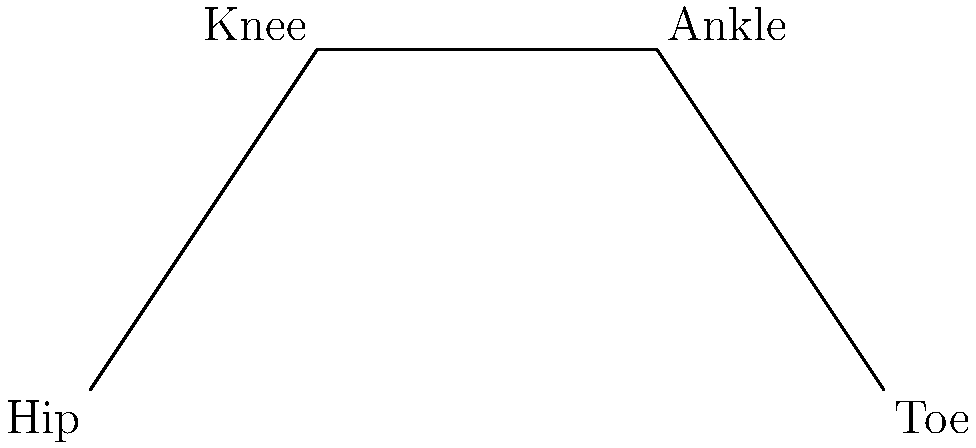In the given stick figure diagram representing a leg during gait analysis, calculate the knee angle $\theta$ formed between the thigh and the lower leg. Use the coordinates of the hip (0,0), knee (2,3), and ankle (5,3) to determine the angle. To calculate the knee angle $\theta$, we'll follow these steps:

1) First, we need to find the vectors representing the thigh and lower leg:
   Thigh vector: $\vec{v_1} = (2-0, 3-0) = (2, 3)$
   Lower leg vector: $\vec{v_2} = (5-2, 3-3) = (3, 0)$

2) The angle between these vectors can be found using the dot product formula:
   $\cos \theta = \frac{\vec{v_1} \cdot \vec{v_2}}{|\vec{v_1}||\vec{v_2}|}$

3) Calculate the dot product:
   $\vec{v_1} \cdot \vec{v_2} = 2(3) + 3(0) = 6$

4) Calculate the magnitudes:
   $|\vec{v_1}| = \sqrt{2^2 + 3^2} = \sqrt{13}$
   $|\vec{v_2}| = \sqrt{3^2 + 0^2} = 3$

5) Substitute into the formula:
   $\cos \theta = \frac{6}{\sqrt{13} \cdot 3}$

6) Take the inverse cosine (arccos) of both sides:
   $\theta = \arccos(\frac{6}{\sqrt{13} \cdot 3})$

7) Calculate the result:
   $\theta \approx 0.9828$ radians

8) Convert to degrees:
   $\theta \approx 0.9828 \cdot \frac{180}{\pi} \approx 56.31°$
Answer: $56.31°$ 